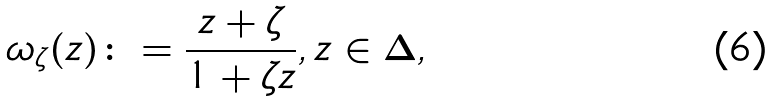Convert formula to latex. <formula><loc_0><loc_0><loc_500><loc_500>\omega _ { \zeta } ( z ) \colon = \frac { z + \zeta } { 1 + \zeta z } , z \in \Delta ,</formula> 